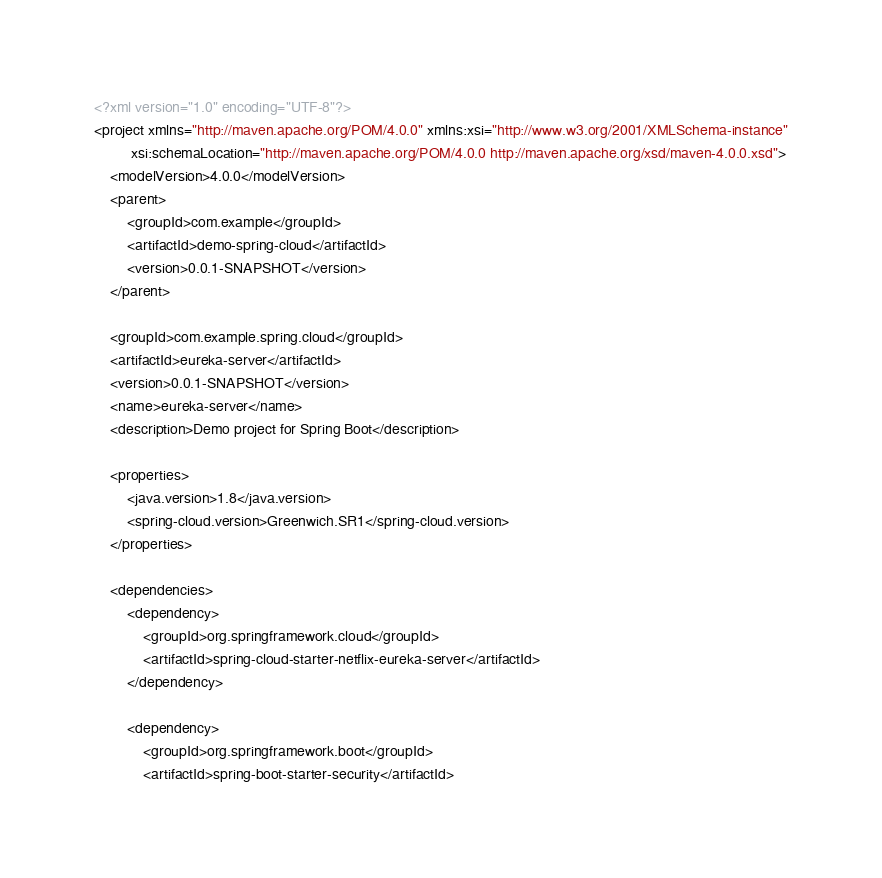<code> <loc_0><loc_0><loc_500><loc_500><_XML_><?xml version="1.0" encoding="UTF-8"?>
<project xmlns="http://maven.apache.org/POM/4.0.0" xmlns:xsi="http://www.w3.org/2001/XMLSchema-instance"
         xsi:schemaLocation="http://maven.apache.org/POM/4.0.0 http://maven.apache.org/xsd/maven-4.0.0.xsd">
    <modelVersion>4.0.0</modelVersion>
    <parent>
        <groupId>com.example</groupId>
        <artifactId>demo-spring-cloud</artifactId>
        <version>0.0.1-SNAPSHOT</version>
    </parent>

    <groupId>com.example.spring.cloud</groupId>
    <artifactId>eureka-server</artifactId>
    <version>0.0.1-SNAPSHOT</version>
    <name>eureka-server</name>
    <description>Demo project for Spring Boot</description>

    <properties>
        <java.version>1.8</java.version>
        <spring-cloud.version>Greenwich.SR1</spring-cloud.version>
    </properties>

    <dependencies>
        <dependency>
            <groupId>org.springframework.cloud</groupId>
            <artifactId>spring-cloud-starter-netflix-eureka-server</artifactId>
        </dependency>

        <dependency>
            <groupId>org.springframework.boot</groupId>
            <artifactId>spring-boot-starter-security</artifactId></code> 